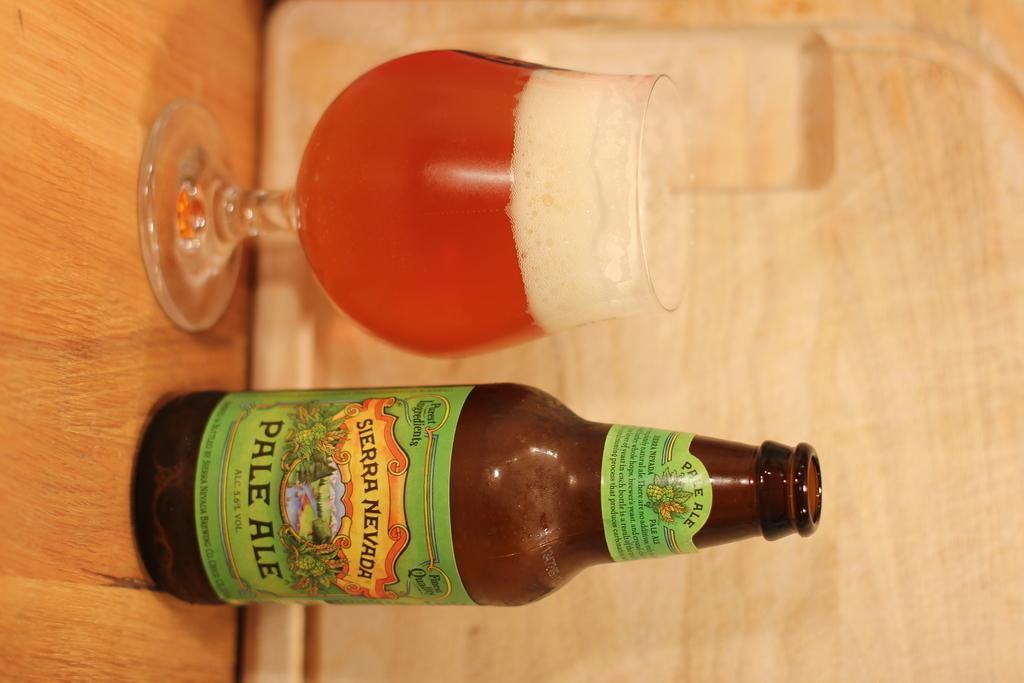Provide a one-sentence caption for the provided image. Sierra Neveda Pale Ale bottle next to a full beer glass on a wooden table. 